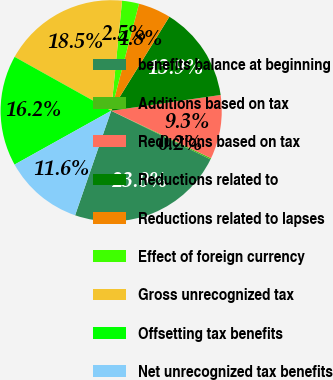Convert chart to OTSL. <chart><loc_0><loc_0><loc_500><loc_500><pie_chart><fcel>benefits balance at beginning<fcel>Additions based on tax<fcel>Reductions based on tax<fcel>Reductions related to<fcel>Reductions related to lapses<fcel>Effect of foreign currency<fcel>Gross unrecognized tax<fcel>Offsetting tax benefits<fcel>Net unrecognized tax benefits<nl><fcel>23.04%<fcel>0.2%<fcel>9.33%<fcel>13.9%<fcel>4.77%<fcel>2.48%<fcel>18.47%<fcel>16.19%<fcel>11.62%<nl></chart> 